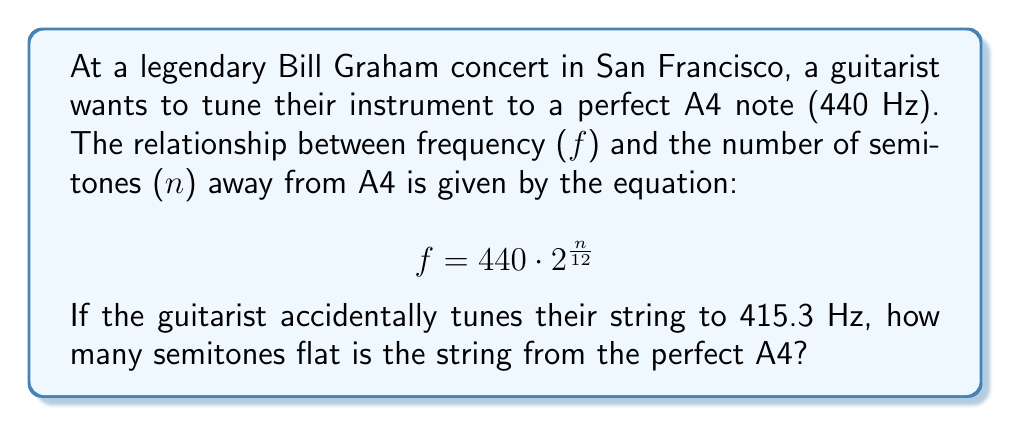Show me your answer to this math problem. Let's approach this step-by-step:

1) We're given the equation: $f = 440 \cdot 2^{\frac{n}{12}}$

2) We know $f = 415.3$ Hz, and we need to solve for $n$.

3) Let's substitute the known values:

   $415.3 = 440 \cdot 2^{\frac{n}{12}}$

4) Divide both sides by 440:

   $\frac{415.3}{440} = 2^{\frac{n}{12}}$

5) Take the natural log of both sides:

   $\ln(\frac{415.3}{440}) = \ln(2^{\frac{n}{12}})$

6) Using the logarithm property $\ln(a^b) = b\ln(a)$:

   $\ln(\frac{415.3}{440}) = \frac{n}{12}\ln(2)$

7) Multiply both sides by 12:

   $12\ln(\frac{415.3}{440}) = n\ln(2)$

8) Divide both sides by $\ln(2)$:

   $\frac{12\ln(\frac{415.3}{440})}{\ln(2)} = n$

9) Calculate the value:

   $n \approx -1.0005$

10) Since we're dealing with semitones, we round to the nearest whole number: -1

The negative value indicates that the string is flat (below the target frequency).
Answer: -1 semitone 